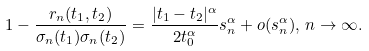<formula> <loc_0><loc_0><loc_500><loc_500>1 - \frac { r _ { n } ( t _ { 1 } , t _ { 2 } ) } { \sigma _ { n } ( t _ { 1 } ) \sigma _ { n } ( t _ { 2 } ) } = \frac { | t _ { 1 } - t _ { 2 } | ^ { \alpha } } { 2 t _ { 0 } ^ { \alpha } } s _ { n } ^ { \alpha } + o ( s _ { n } ^ { \alpha } ) , \, n \to \infty .</formula> 